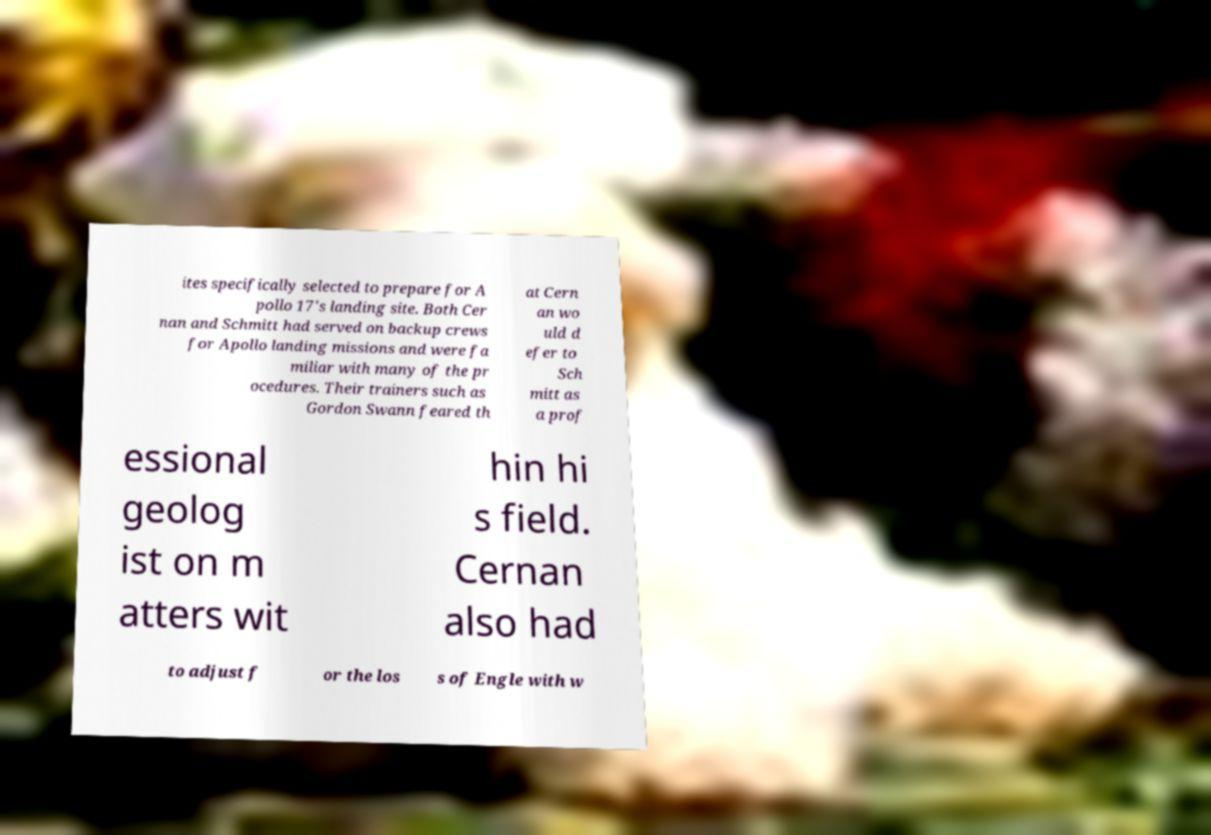Please identify and transcribe the text found in this image. ites specifically selected to prepare for A pollo 17's landing site. Both Cer nan and Schmitt had served on backup crews for Apollo landing missions and were fa miliar with many of the pr ocedures. Their trainers such as Gordon Swann feared th at Cern an wo uld d efer to Sch mitt as a prof essional geolog ist on m atters wit hin hi s field. Cernan also had to adjust f or the los s of Engle with w 